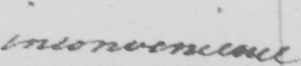Please transcribe the handwritten text in this image. inconvenience 